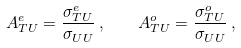Convert formula to latex. <formula><loc_0><loc_0><loc_500><loc_500>A _ { T U } ^ { e } = \frac { \sigma _ { T U } ^ { e } } { \sigma _ { U U } } \, , \quad A _ { T U } ^ { o } = \frac { \sigma _ { T U } ^ { o } } { \sigma _ { U U } } \, ,</formula> 